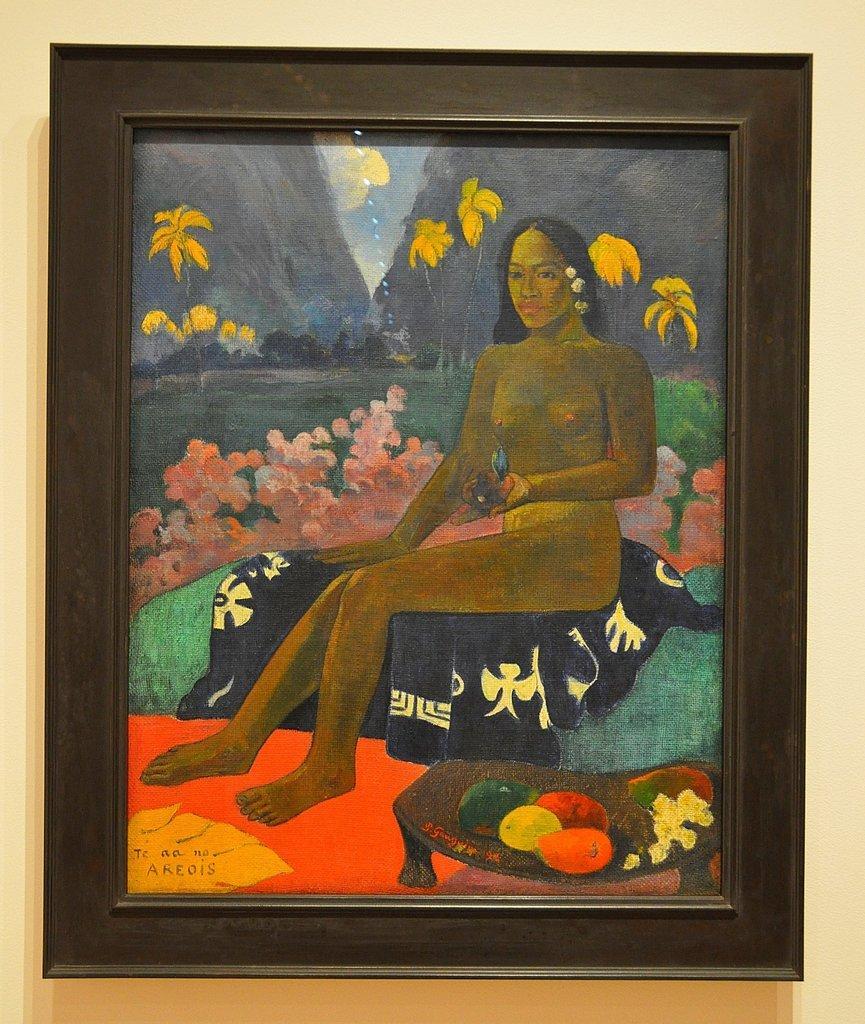Could you give a brief overview of what you see in this image? In the center of the image there is a wall. On the wall, we can see one photo frame. On the photo frame, we can see some painting, in which we can see the sky, clouds, hills, trees, plants, one person sitting and holding some object, one cloth, fruits on the wooden object and a few other objects. And we can see some text on the photo frame. 